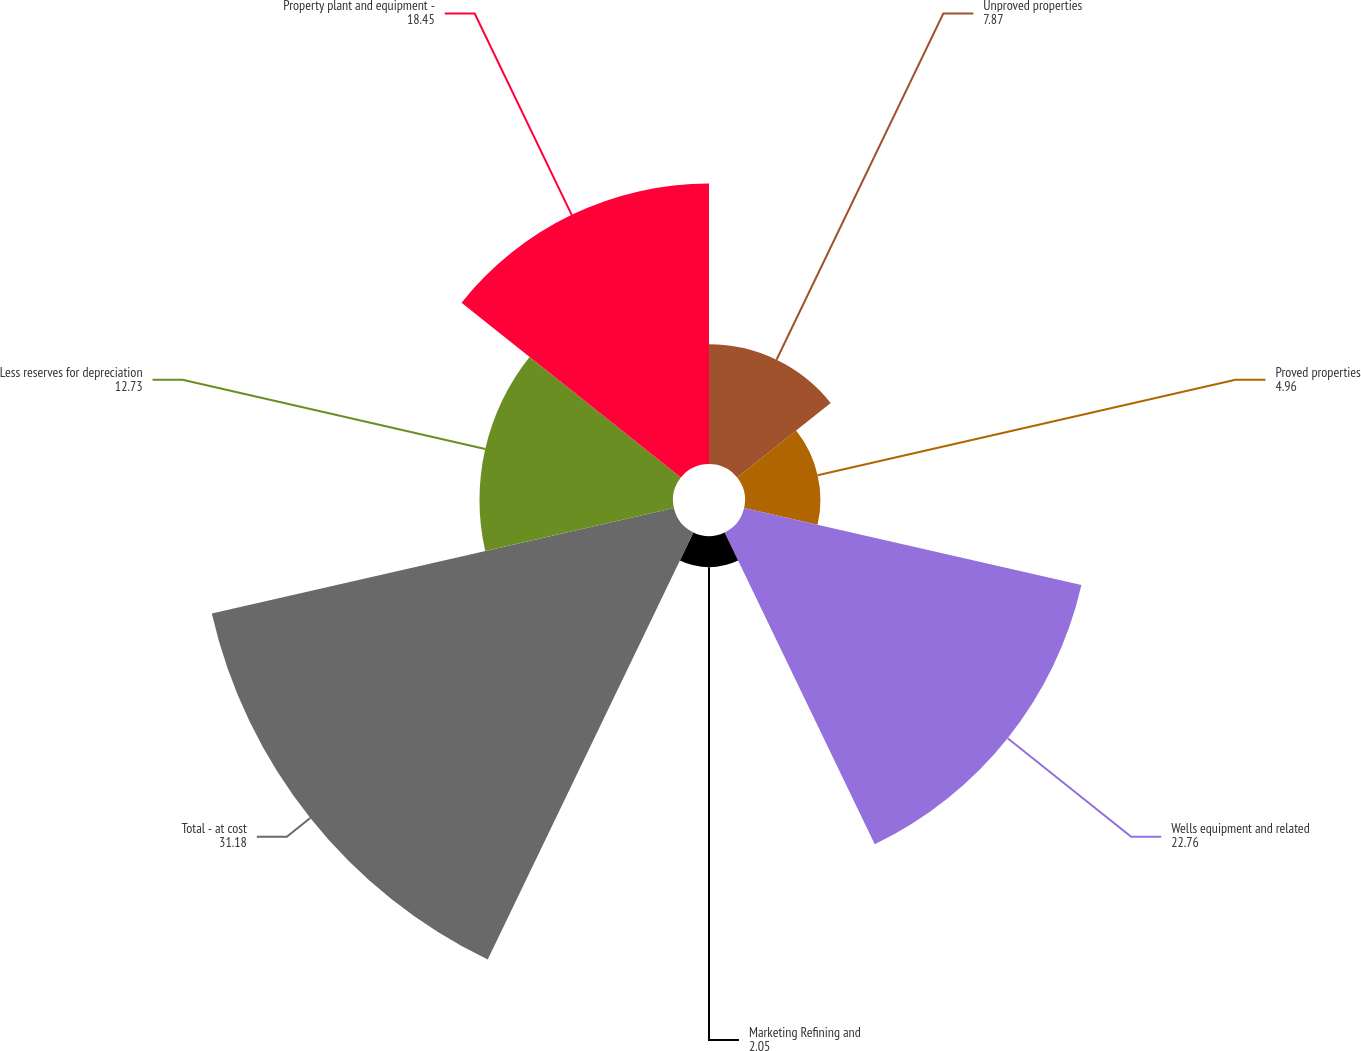Convert chart to OTSL. <chart><loc_0><loc_0><loc_500><loc_500><pie_chart><fcel>Unproved properties<fcel>Proved properties<fcel>Wells equipment and related<fcel>Marketing Refining and<fcel>Total - at cost<fcel>Less reserves for depreciation<fcel>Property plant and equipment -<nl><fcel>7.87%<fcel>4.96%<fcel>22.76%<fcel>2.05%<fcel>31.18%<fcel>12.73%<fcel>18.45%<nl></chart> 